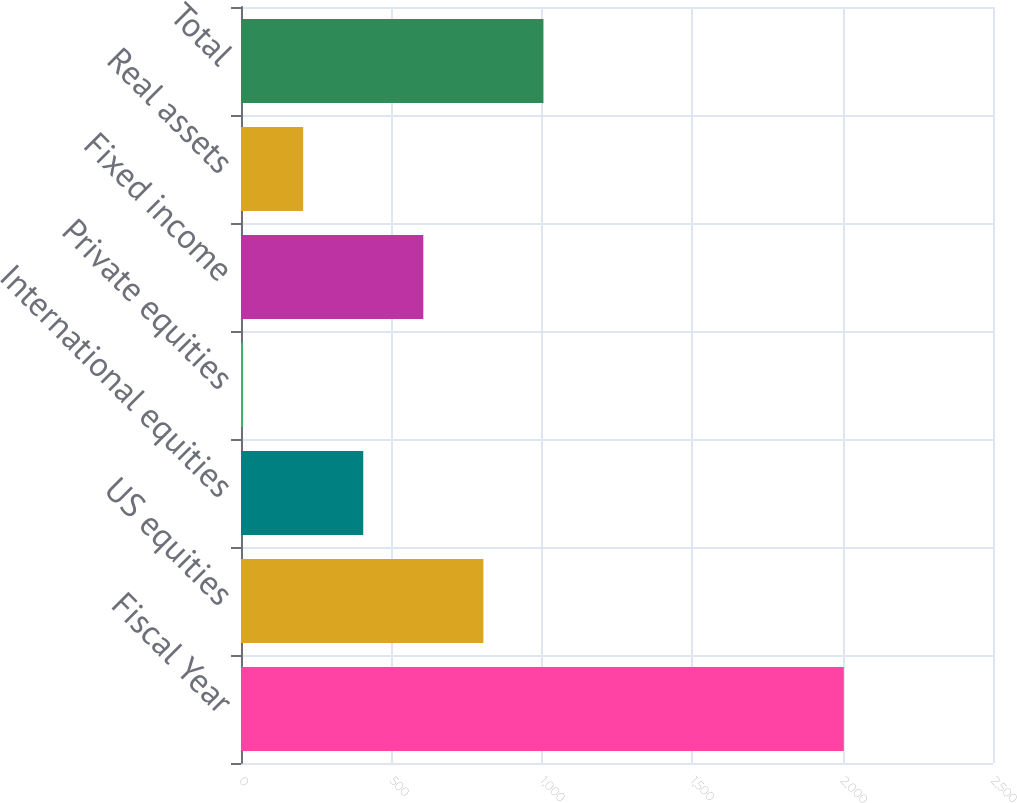Convert chart to OTSL. <chart><loc_0><loc_0><loc_500><loc_500><bar_chart><fcel>Fiscal Year<fcel>US equities<fcel>International equities<fcel>Private equities<fcel>Fixed income<fcel>Real assets<fcel>Total<nl><fcel>2004<fcel>805.8<fcel>406.4<fcel>7<fcel>606.1<fcel>206.7<fcel>1005.5<nl></chart> 